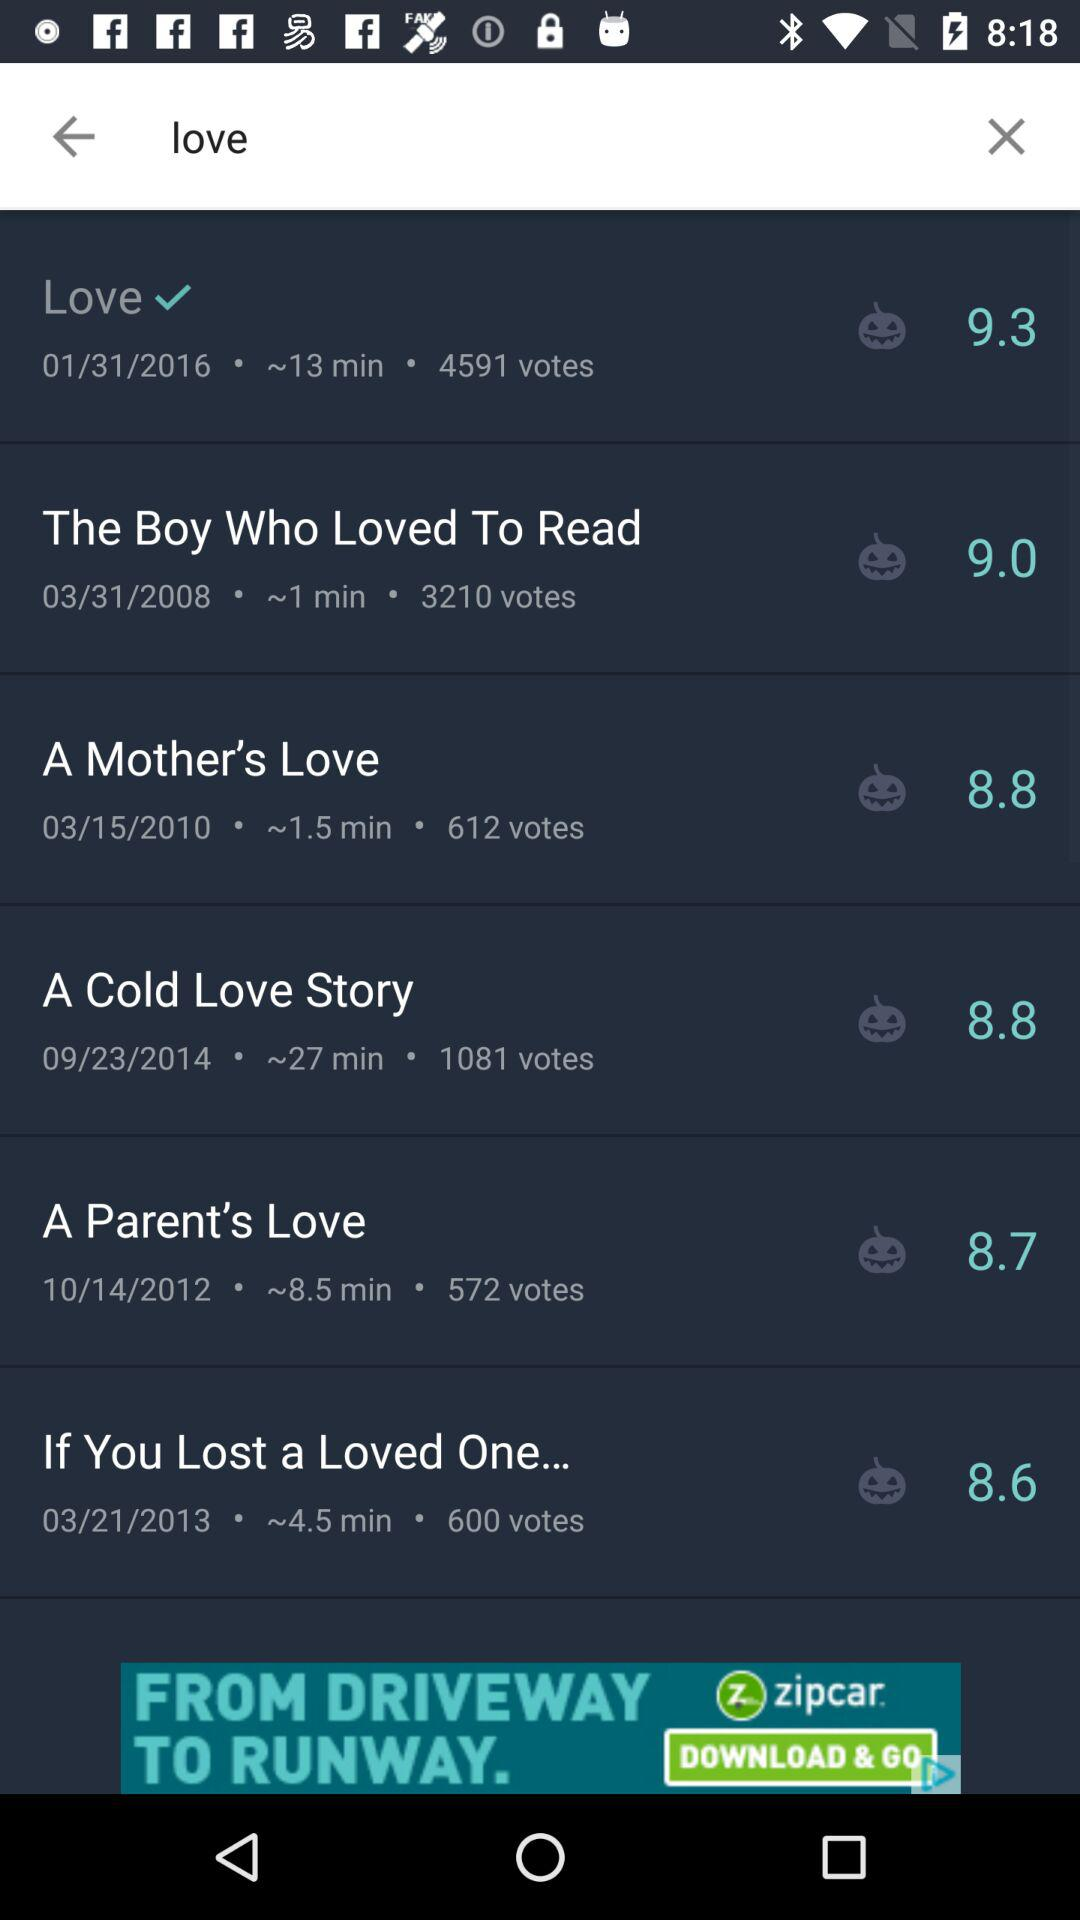Which video has the most votes?
Answer the question using a single word or phrase. Love 